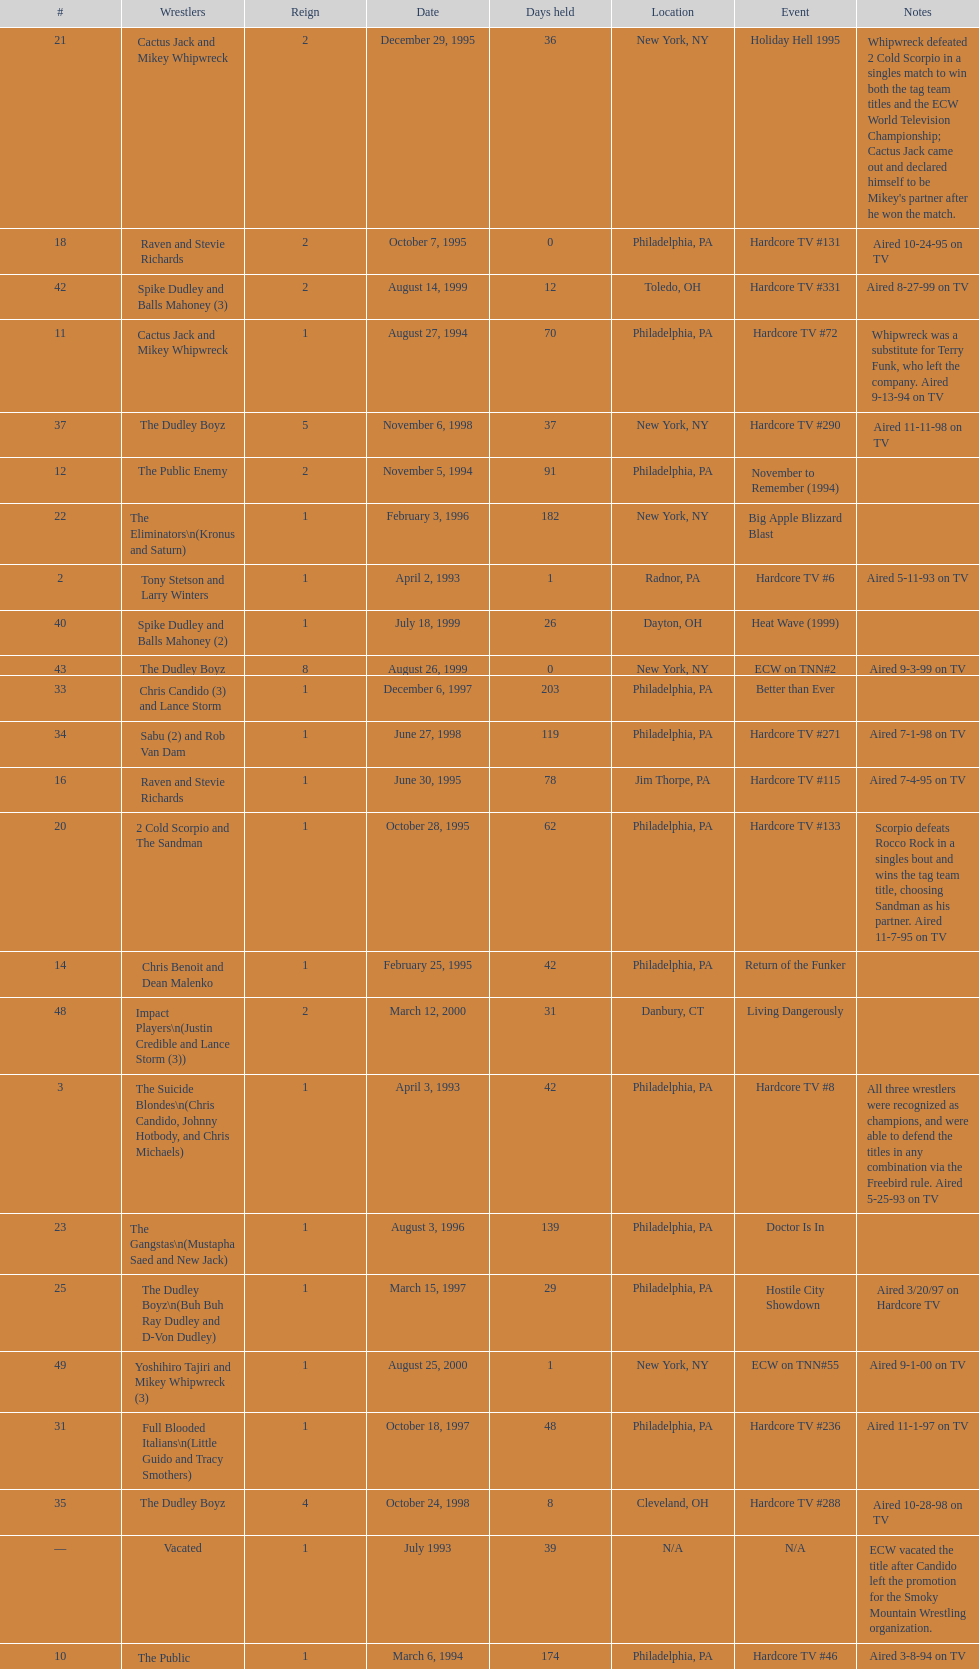Give me the full table as a dictionary. {'header': ['#', 'Wrestlers', 'Reign', 'Date', 'Days held', 'Location', 'Event', 'Notes'], 'rows': [['21', 'Cactus Jack and Mikey Whipwreck', '2', 'December 29, 1995', '36', 'New York, NY', 'Holiday Hell 1995', "Whipwreck defeated 2 Cold Scorpio in a singles match to win both the tag team titles and the ECW World Television Championship; Cactus Jack came out and declared himself to be Mikey's partner after he won the match."], ['18', 'Raven and Stevie Richards', '2', 'October 7, 1995', '0', 'Philadelphia, PA', 'Hardcore TV #131', 'Aired 10-24-95 on TV'], ['42', 'Spike Dudley and Balls Mahoney (3)', '2', 'August 14, 1999', '12', 'Toledo, OH', 'Hardcore TV #331', 'Aired 8-27-99 on TV'], ['11', 'Cactus Jack and Mikey Whipwreck', '1', 'August 27, 1994', '70', 'Philadelphia, PA', 'Hardcore TV #72', 'Whipwreck was a substitute for Terry Funk, who left the company. Aired 9-13-94 on TV'], ['37', 'The Dudley Boyz', '5', 'November 6, 1998', '37', 'New York, NY', 'Hardcore TV #290', 'Aired 11-11-98 on TV'], ['12', 'The Public Enemy', '2', 'November 5, 1994', '91', 'Philadelphia, PA', 'November to Remember (1994)', ''], ['22', 'The Eliminators\\n(Kronus and Saturn)', '1', 'February 3, 1996', '182', 'New York, NY', 'Big Apple Blizzard Blast', ''], ['2', 'Tony Stetson and Larry Winters', '1', 'April 2, 1993', '1', 'Radnor, PA', 'Hardcore TV #6', 'Aired 5-11-93 on TV'], ['40', 'Spike Dudley and Balls Mahoney (2)', '1', 'July 18, 1999', '26', 'Dayton, OH', 'Heat Wave (1999)', ''], ['43', 'The Dudley Boyz', '8', 'August 26, 1999', '0', 'New York, NY', 'ECW on TNN#2', 'Aired 9-3-99 on TV'], ['33', 'Chris Candido (3) and Lance Storm', '1', 'December 6, 1997', '203', 'Philadelphia, PA', 'Better than Ever', ''], ['34', 'Sabu (2) and Rob Van Dam', '1', 'June 27, 1998', '119', 'Philadelphia, PA', 'Hardcore TV #271', 'Aired 7-1-98 on TV'], ['16', 'Raven and Stevie Richards', '1', 'June 30, 1995', '78', 'Jim Thorpe, PA', 'Hardcore TV #115', 'Aired 7-4-95 on TV'], ['20', '2 Cold Scorpio and The Sandman', '1', 'October 28, 1995', '62', 'Philadelphia, PA', 'Hardcore TV #133', 'Scorpio defeats Rocco Rock in a singles bout and wins the tag team title, choosing Sandman as his partner. Aired 11-7-95 on TV'], ['14', 'Chris Benoit and Dean Malenko', '1', 'February 25, 1995', '42', 'Philadelphia, PA', 'Return of the Funker', ''], ['48', 'Impact Players\\n(Justin Credible and Lance Storm (3))', '2', 'March 12, 2000', '31', 'Danbury, CT', 'Living Dangerously', ''], ['3', 'The Suicide Blondes\\n(Chris Candido, Johnny Hotbody, and Chris Michaels)', '1', 'April 3, 1993', '42', 'Philadelphia, PA', 'Hardcore TV #8', 'All three wrestlers were recognized as champions, and were able to defend the titles in any combination via the Freebird rule. Aired 5-25-93 on TV'], ['23', 'The Gangstas\\n(Mustapha Saed and New Jack)', '1', 'August 3, 1996', '139', 'Philadelphia, PA', 'Doctor Is In', ''], ['25', 'The Dudley Boyz\\n(Buh Buh Ray Dudley and D-Von Dudley)', '1', 'March 15, 1997', '29', 'Philadelphia, PA', 'Hostile City Showdown', 'Aired 3/20/97 on Hardcore TV'], ['49', 'Yoshihiro Tajiri and Mikey Whipwreck (3)', '1', 'August 25, 2000', '1', 'New York, NY', 'ECW on TNN#55', 'Aired 9-1-00 on TV'], ['31', 'Full Blooded Italians\\n(Little Guido and Tracy Smothers)', '1', 'October 18, 1997', '48', 'Philadelphia, PA', 'Hardcore TV #236', 'Aired 11-1-97 on TV'], ['35', 'The Dudley Boyz', '4', 'October 24, 1998', '8', 'Cleveland, OH', 'Hardcore TV #288', 'Aired 10-28-98 on TV'], ['—', 'Vacated', '1', 'July 1993', '39', 'N/A', 'N/A', 'ECW vacated the title after Candido left the promotion for the Smoky Mountain Wrestling organization.'], ['10', 'The Public Enemy\\n(Johnny Grunge and Rocco Rock)', '1', 'March 6, 1994', '174', 'Philadelphia, PA', 'Hardcore TV #46', 'Aired 3-8-94 on TV'], ['17', 'The Pitbulls\\n(Pitbull #1 and Pitbull #2)', '1', 'September 16, 1995', '21', 'Philadelphia, PA', "Gangsta's Paradise", ''], ['13', 'Sabu and The Tazmaniac (2)', '1', 'February 4, 1995', '21', 'Philadelphia, PA', 'Double Tables', ''], ['8', 'Tommy Dreamer and Johnny Gunn', '1', 'November 13, 1993', '21', 'Philadelphia, PA', 'November to Remember (1993)', ''], ['46', 'Tommy Dreamer (3) and Masato Tanaka (2)', '1', 'February 26, 2000', '7', 'Cincinnati, OH', 'Hardcore TV #358', 'Aired 3-7-00 on TV'], ['28', 'The Gangstas', '2', 'July 19, 1997', '29', 'Philadelphia, PA', 'Heat Wave 1997/Hardcore TV #222', 'Aired 7-24-97 on TV'], ['26', 'The Eliminators', '3', 'April 13, 1997', '68', 'Philadelphia, PA', 'Barely Legal', ''], ['—', 'Vacated', '3', 'April 22, 2000', '125', 'Philadelphia, PA', 'Live event', 'At CyberSlam, Justin Credible threw down the titles to become eligible for the ECW World Heavyweight Championship. Storm later left for World Championship Wrestling. As a result of the circumstances, Credible vacated the championship.'], ['19', 'The Public Enemy', '4', 'October 7, 1995', '21', 'Philadelphia, PA', 'Hardcore TV #131', 'Aired 10-24-95 on TV'], ['30', 'The Gangstanators\\n(Kronus (4) and New Jack (3))', '1', 'September 20, 1997', '28', 'Philadelphia, PA', 'As Good as it Gets', 'Aired 9-27-97 on TV'], ['29', 'The Dudley Boyz', '3', 'August 17, 1997', '95', 'Fort Lauderdale, FL', 'Hardcore Heaven (1997)', 'The Dudley Boyz won the championship via forfeit as a result of Mustapha Saed leaving the promotion before Hardcore Heaven took place.'], ['38', 'Sabu (3) and Rob Van Dam', '2', 'December 13, 1998', '125', 'Tokyo, Japan', 'ECW/FMW Supershow II', 'Aired 12-16-98 on TV'], ['47', 'Mike Awesome and Raven (4)', '1', 'March 4, 2000', '8', 'Philadelphia, PA', 'ECW on TNN#29', 'Aired 3-10-00 on TV'], ['6', 'The Dark Patriot and Eddie Gilbert', '1', 'August 8, 1993', '54', 'Philadelphia, PA', 'Hardcore TV #21', 'The Dark Patriot and Gilbert won the titles in a tournament final. Aired 9-7-93 on TV'], ['9', 'Kevin Sullivan and The Tazmaniac', '1', 'December 4, 1993', '92', 'Philadelphia, PA', 'Hardcore TV #35', 'Defeat Dreamer and Shane Douglas, who was substituting for an injured Gunn. After the bout, Douglas turned against Dreamer and became a heel. Aired 12-14-93 on TV'], ['51', 'Danny Doring and Roadkill', '1', 'December 3, 2000', '122', 'New York, NY', 'Massacre on 34th Street', "Doring and Roadkill's reign was the final one in the title's history."], ['24', 'The Eliminators', '2', 'December 20, 1996', '85', 'Middletown, NY', 'Hardcore TV #193', 'Aired on 12/31/96 on Hardcore TV'], ['45', 'Impact Players\\n(Justin Credible and Lance Storm (2))', '1', 'January 9, 2000', '48', 'Birmingham, AL', 'Guilty as Charged (2000)', ''], ['27', 'The Dudley Boyz', '2', 'June 20, 1997', '29', 'Waltham, MA', 'Hardcore TV #218', 'The Dudley Boyz defeated Kronus in a handicap match as a result of a sidelining injury sustained by Saturn. Aired 6-26-97 on TV'], ['39', 'The Dudley Boyz', '6', 'April 17, 1999', '92', 'Buffalo, NY', 'Hardcore TV #313', 'D-Von Dudley defeated Van Dam in a singles match to win the championship for his team. Aired 4-23-99 on TV'], ['44', 'Tommy Dreamer (2) and Raven (3)', '1', 'August 26, 1999', '136', 'New York, NY', 'ECW on TNN#2', 'Aired 9-3-99 on TV'], ['5', 'The Suicide Blondes', '2', 'May 15, 1993', '46', 'Philadelphia, PA', 'Hardcore TV #15', 'Aired 7-20-93 on TV'], ['7', 'Johnny Hotbody (3) and Tony Stetson (2)', '1', 'October 1, 1993', '43', 'Philadelphia, PA', 'Bloodfest: Part 1', 'Hotbody and Stetson were awarded the titles by ECW.'], ['1', 'The Super Destroyers\\n(A.J. Petrucci and Doug Stahl)', '1', 'June 23, 1992', '283', 'Philadelphia, PA', 'Live event', 'Petrucci and Stahl won the titles in a tournament final.'], ['36', 'Balls Mahoney and Masato Tanaka', '1', 'November 1, 1998', '5', 'New Orleans, LA', 'November to Remember (1998)', ''], ['4', 'The Super Destroyers', '2', 'May 15, 1993', '0', 'Philadelphia, PA', 'Hardcore TV #14', 'Aired 7-6-93 on TV'], ['32', 'Doug Furnas and Phil LaFon', '1', 'December 5, 1997', '1', 'Waltham, MA', 'Live event', ''], ['15', 'The Public Enemy', '3', 'April 8, 1995', '83', 'Philadelphia, PA', 'Three Way Dance', 'Also def. Rick Steiner (who was a substitute for Sabu) and Taz in 3 way dance'], ['41', 'The Dudley Boyz', '7', 'August 13, 1999', '1', 'Cleveland, OH', 'Hardcore TV #330', 'Aired 8-20-99 on TV'], ['50', 'Full Blooded Italians\\n(Little Guido (2) and Tony Mamaluke)', '1', 'August 26, 2000', '99', 'New York, NY', 'ECW on TNN#56', 'Aired 9-8-00 on TV'], ['—', 'Vacated', '2', 'October 1, 1993', '0', 'Philadelphia, PA', 'Bloodfest: Part 1', 'ECW vacated the championships after The Dark Patriot and Eddie Gilbert left the organization.']]} What is the total days held on # 1st? 283. 